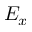<formula> <loc_0><loc_0><loc_500><loc_500>E _ { x }</formula> 